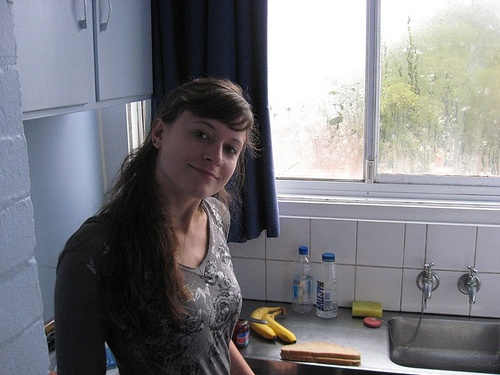Describe the objects in this image and their specific colors. I can see people in gray, black, and darkgray tones, sink in gray and black tones, bottle in gray, navy, and black tones, sandwich in gray, maroon, tan, and lightgray tones, and banana in gray, maroon, tan, and olive tones in this image. 